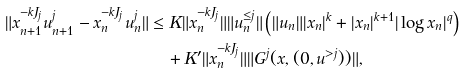<formula> <loc_0><loc_0><loc_500><loc_500>\| x _ { n + 1 } ^ { - k J _ { j } } u _ { n + 1 } ^ { j } - x _ { n } ^ { - k J _ { j } } u _ { n } ^ { j } \| & \leq K \| x _ { n } ^ { - k J _ { j } } \| \| u _ { n } ^ { \leq j } \| \left ( \| u _ { n } \| | x _ { n } | ^ { k } + | x _ { n } | ^ { k + 1 } | \log x _ { n } | ^ { q } \right ) \\ & \quad + K ^ { \prime } \| x _ { n } ^ { - k J _ { j } } \| \| G ^ { j } ( x , ( 0 , u ^ { > j } ) ) \| ,</formula> 